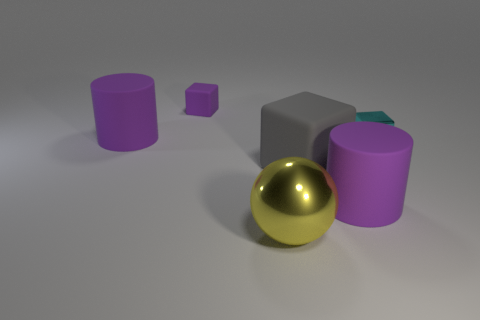Add 1 small gray objects. How many objects exist? 7 Subtract all purple blocks. How many blocks are left? 2 Subtract all gray cubes. How many cubes are left? 2 Subtract 1 purple cylinders. How many objects are left? 5 Subtract all cylinders. How many objects are left? 4 Subtract all blue spheres. Subtract all gray blocks. How many spheres are left? 1 Subtract all brown cylinders. How many red spheres are left? 0 Subtract all big purple rubber cylinders. Subtract all shiny balls. How many objects are left? 3 Add 5 cylinders. How many cylinders are left? 7 Add 4 big green cylinders. How many big green cylinders exist? 4 